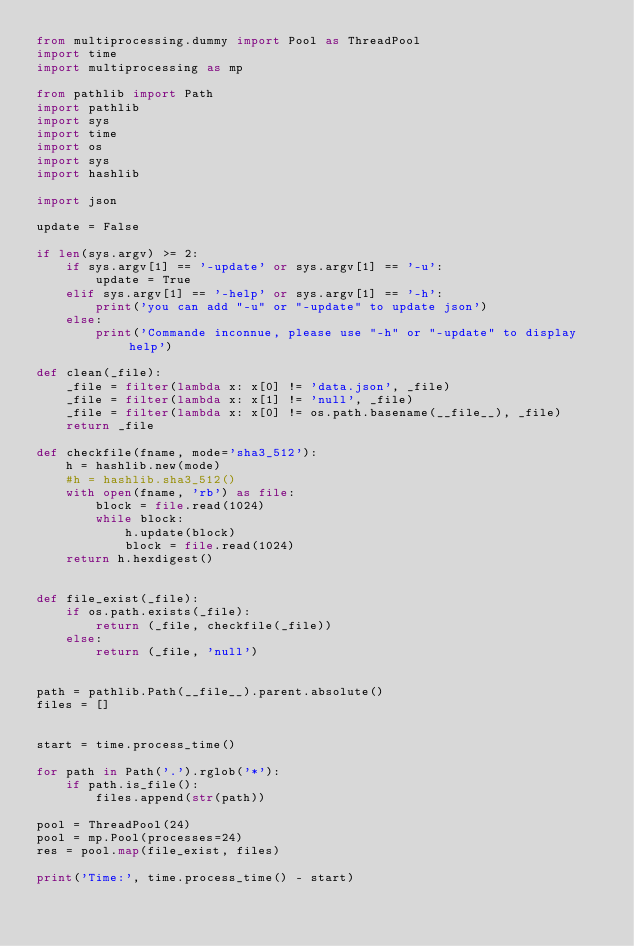<code> <loc_0><loc_0><loc_500><loc_500><_Python_>from multiprocessing.dummy import Pool as ThreadPool
import time
import multiprocessing as mp

from pathlib import Path
import pathlib
import sys
import time
import os
import sys
import hashlib

import json

update = False

if len(sys.argv) >= 2:
    if sys.argv[1] == '-update' or sys.argv[1] == '-u':
        update = True
    elif sys.argv[1] == '-help' or sys.argv[1] == '-h':
        print('you can add "-u" or "-update" to update json')
    else:
        print('Commande inconnue, please use "-h" or "-update" to display help')

def clean(_file):
    _file = filter(lambda x: x[0] != 'data.json', _file)
    _file = filter(lambda x: x[1] != 'null', _file)
    _file = filter(lambda x: x[0] != os.path.basename(__file__), _file)
    return _file

def checkfile(fname, mode='sha3_512'):
    h = hashlib.new(mode)
    #h = hashlib.sha3_512()
    with open(fname, 'rb') as file:
        block = file.read(1024)
        while block:
            h.update(block)
            block = file.read(1024)
    return h.hexdigest()


def file_exist(_file):
    if os.path.exists(_file):
        return (_file, checkfile(_file))
    else:
        return (_file, 'null')


path = pathlib.Path(__file__).parent.absolute()
files = []


start = time.process_time()

for path in Path('.').rglob('*'):
    if path.is_file():
        files.append(str(path))

pool = ThreadPool(24)
pool = mp.Pool(processes=24)
res = pool.map(file_exist, files)

print('Time:', time.process_time() - start)
</code> 